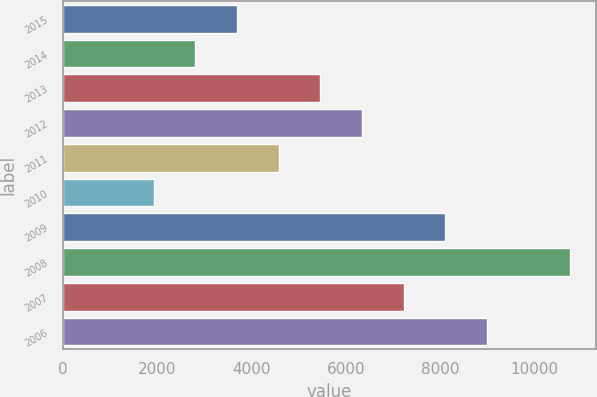Convert chart. <chart><loc_0><loc_0><loc_500><loc_500><bar_chart><fcel>2015<fcel>2014<fcel>2013<fcel>2012<fcel>2011<fcel>2010<fcel>2009<fcel>2008<fcel>2007<fcel>2006<nl><fcel>3692.8<fcel>2809.4<fcel>5459.6<fcel>6343<fcel>4576.2<fcel>1926<fcel>8109.8<fcel>10760<fcel>7226.4<fcel>8993.2<nl></chart> 